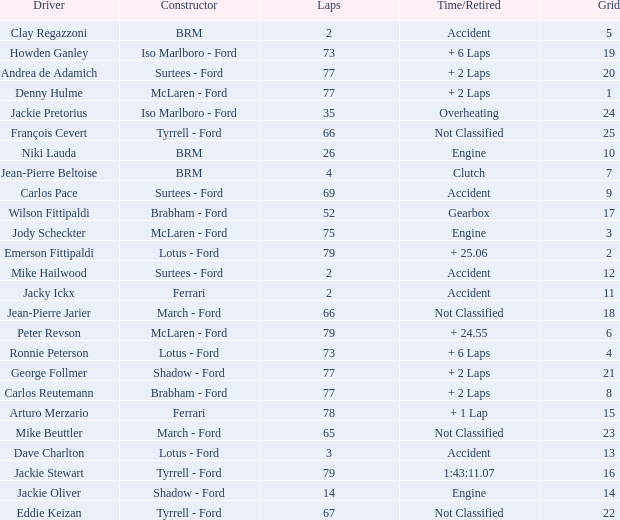How much time is required for less than 35 laps and less than 10 grids? Clutch, Accident. 